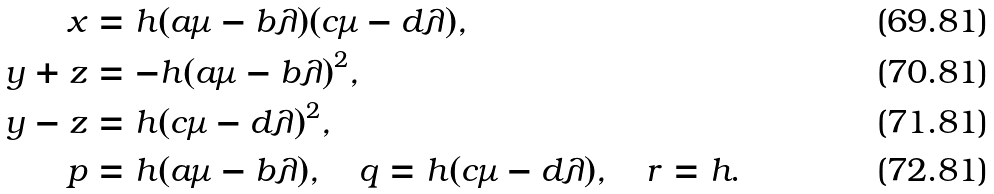<formula> <loc_0><loc_0><loc_500><loc_500>x & = h ( a \mu - b \lambda ) ( c \mu - d \lambda ) , \\ y + z & = - h ( a \mu - b \lambda ) ^ { 2 } , \\ y - z & = h ( c \mu - d \lambda ) ^ { 2 } , \\ p & = h ( a \mu - b \lambda ) , \quad q = h ( c \mu - d \lambda ) , \quad r = h .</formula> 